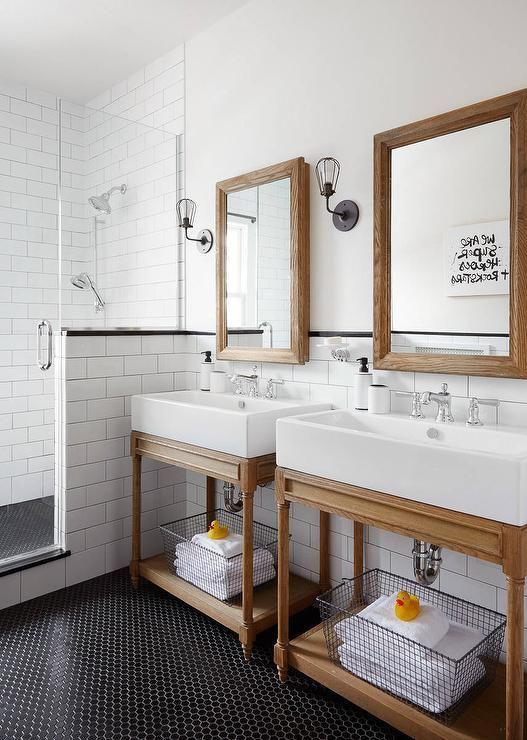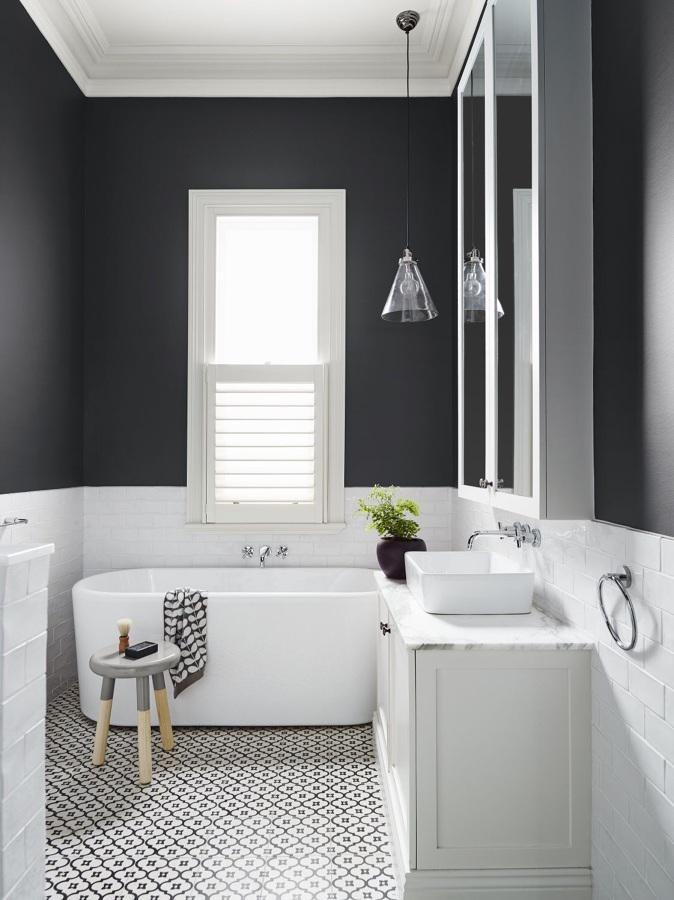The first image is the image on the left, the second image is the image on the right. For the images displayed, is the sentence "The bathroom on the right has a black-and-white diamond pattern floor and a long brown sink vanity." factually correct? Answer yes or no. No. 